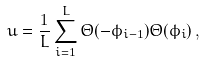<formula> <loc_0><loc_0><loc_500><loc_500>u = \frac { 1 } { L } \sum _ { i = 1 } ^ { L } \Theta ( - \phi _ { i - 1 } ) \Theta ( \phi _ { i } ) \, ,</formula> 